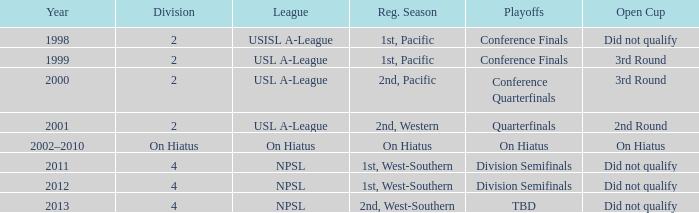Which open cup was in 2012? Did not qualify. 